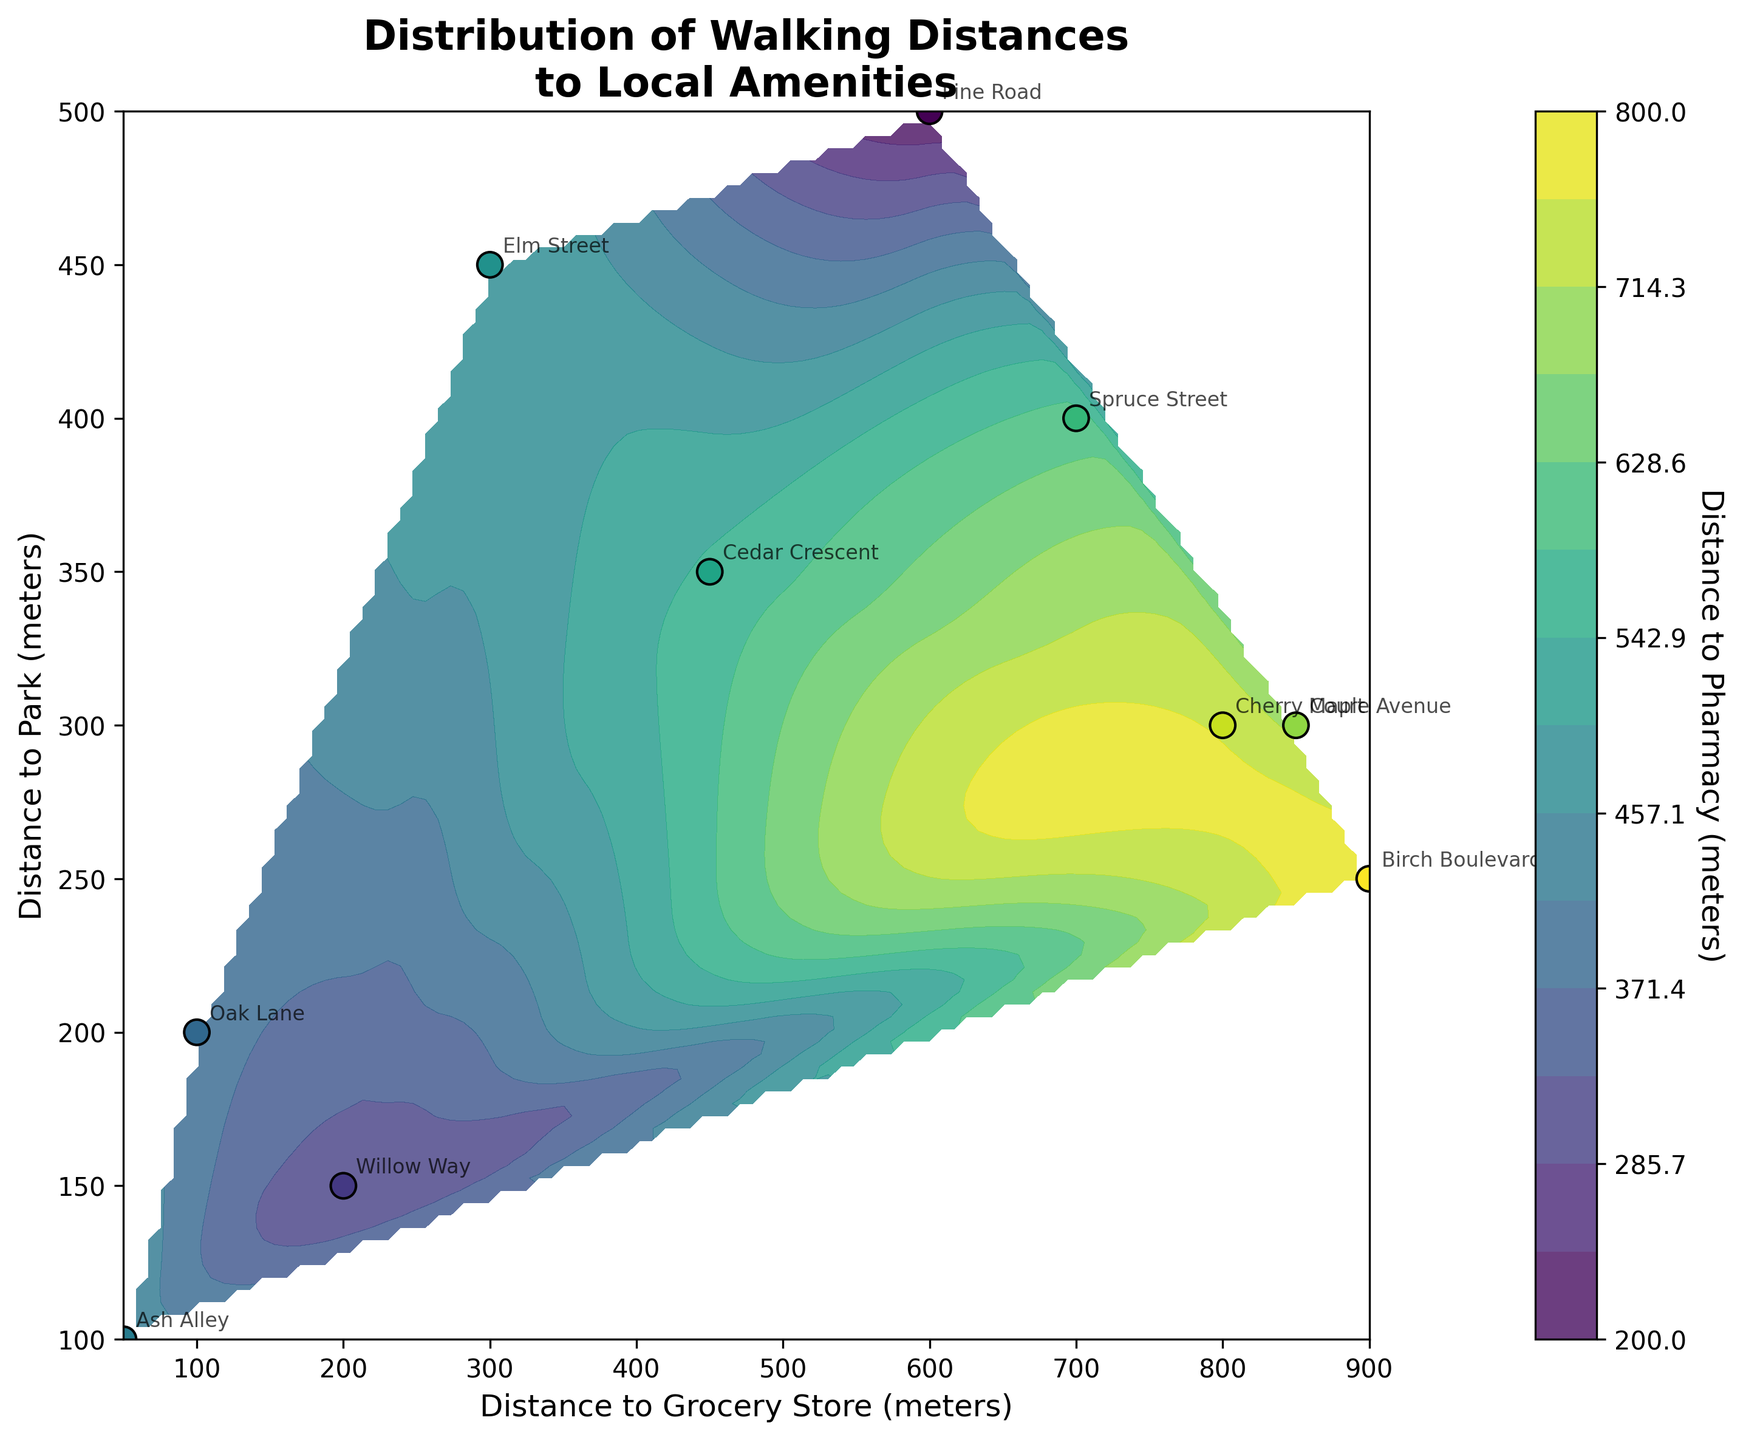What is the title of the plot? The title of the plot is located at the top and usually gives an overview of what the plot represents. In this case, the title says "Distribution of Walking Distances to Local Amenities."
Answer: Distribution of Walking Distances to Local Amenities How many data points are plotted in the scatter plot? The scatter plot shows individual data points for each location. In this case, we have 10 locations, each represented by a data point.
Answer: 10 Which location has the shortest walking distance to a park? The location closest to the bottom left on the Y-axis, which represents "Distance to Park," is "Ash Alley" with a distance of 100 meters.
Answer: Ash Alley Which data point represents the farthest distance to a pharmacy, and what is that distance? Look for the data point where the color represents the highest value in the color bar, which represents distances to pharmacies. "Birch Boulevard" is the farthest with 800 meters.
Answer: Birch Boulevard, 800 meters What are the X and Y axes representing in this plot? The axes labels will tell you what each axis represents. The X-axis represents "Distance to Grocery Store (meters)" and the Y-axis represents "Distance to Park (meters)."
Answer: Distance to Grocery Store (meters) and Distance to Park (meters) Which location is closest to both a grocery store and a park? Look for the data point towards the bottom left corner near the origin on both X and Y axes. "Ash Alley" has distances of 50 meters to the grocery store and 100 meters to the park.
Answer: Ash Alley Compare the walking distances to the pharmacy for Elm Street and Willow Way. Which one is closer? Elm Street and Willow Way's distances can be identified by their positions indicated on the X and Y axes and their corresponding colors. Elm Street has 500 meters, and Willow Way has 300 meters, so Willow Way is closer.
Answer: Willow Way Which locations have a distance to the pharmacy greater than 700 meters? Check the color gradient on the contour plot for values above 700 meters and find the corresponding locations. "Maple Avenue," "Birch Boulevard," and "Cherry Court" are beyond 700 meters.
Answer: Maple Avenue, Birch Boulevard, Cherry Court What is the range of distances to a grocery store covered in this plot? The X-axis will give the minimum and maximum values for "Distance to Grocery Store (meters)." Here it ranges from 50 meters (Ash Alley) to 900 meters (Birch Boulevard).
Answer: 50 meters to 900 meters 